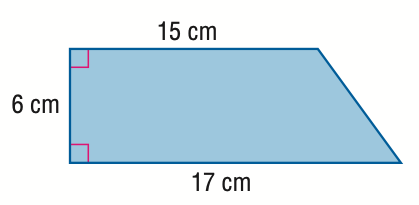Question: Find the area of the trapezoid.
Choices:
A. 44.3
B. 48
C. 96
D. 192
Answer with the letter. Answer: C 